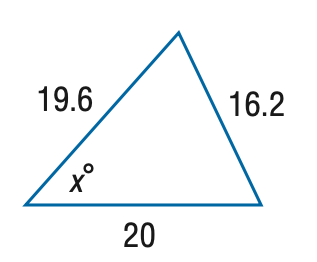Question: Find x. Round the angle measure to the nearest degree.
Choices:
A. 43
B. 48
C. 53
D. 58
Answer with the letter. Answer: B 